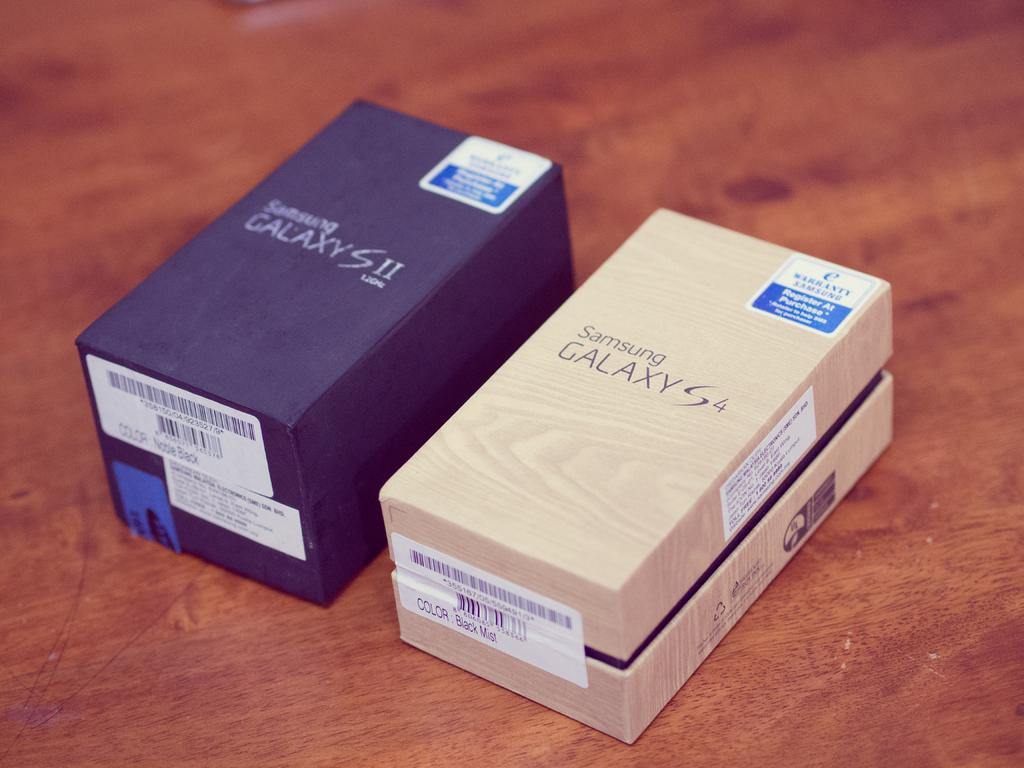<image>
Give a short and clear explanation of the subsequent image. Two Samsung Galaxy phone box's sit on a wooden table 